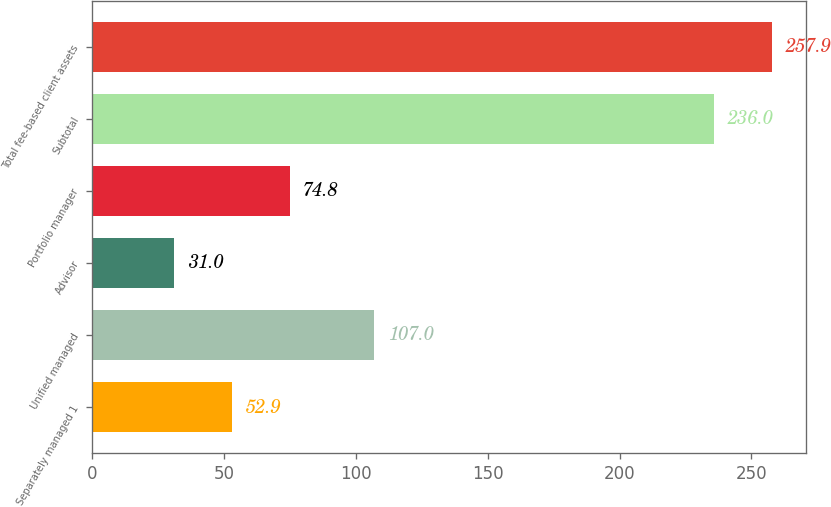Convert chart. <chart><loc_0><loc_0><loc_500><loc_500><bar_chart><fcel>Separately managed 1<fcel>Unified managed<fcel>Advisor<fcel>Portfolio manager<fcel>Subtotal<fcel>Total fee-based client assets<nl><fcel>52.9<fcel>107<fcel>31<fcel>74.8<fcel>236<fcel>257.9<nl></chart> 